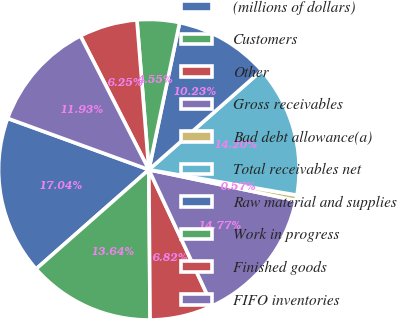<chart> <loc_0><loc_0><loc_500><loc_500><pie_chart><fcel>(millions of dollars)<fcel>Customers<fcel>Other<fcel>Gross receivables<fcel>Bad debt allowance(a)<fcel>Total receivables net<fcel>Raw material and supplies<fcel>Work in progress<fcel>Finished goods<fcel>FIFO inventories<nl><fcel>17.04%<fcel>13.64%<fcel>6.82%<fcel>14.77%<fcel>0.57%<fcel>14.2%<fcel>10.23%<fcel>4.55%<fcel>6.25%<fcel>11.93%<nl></chart> 